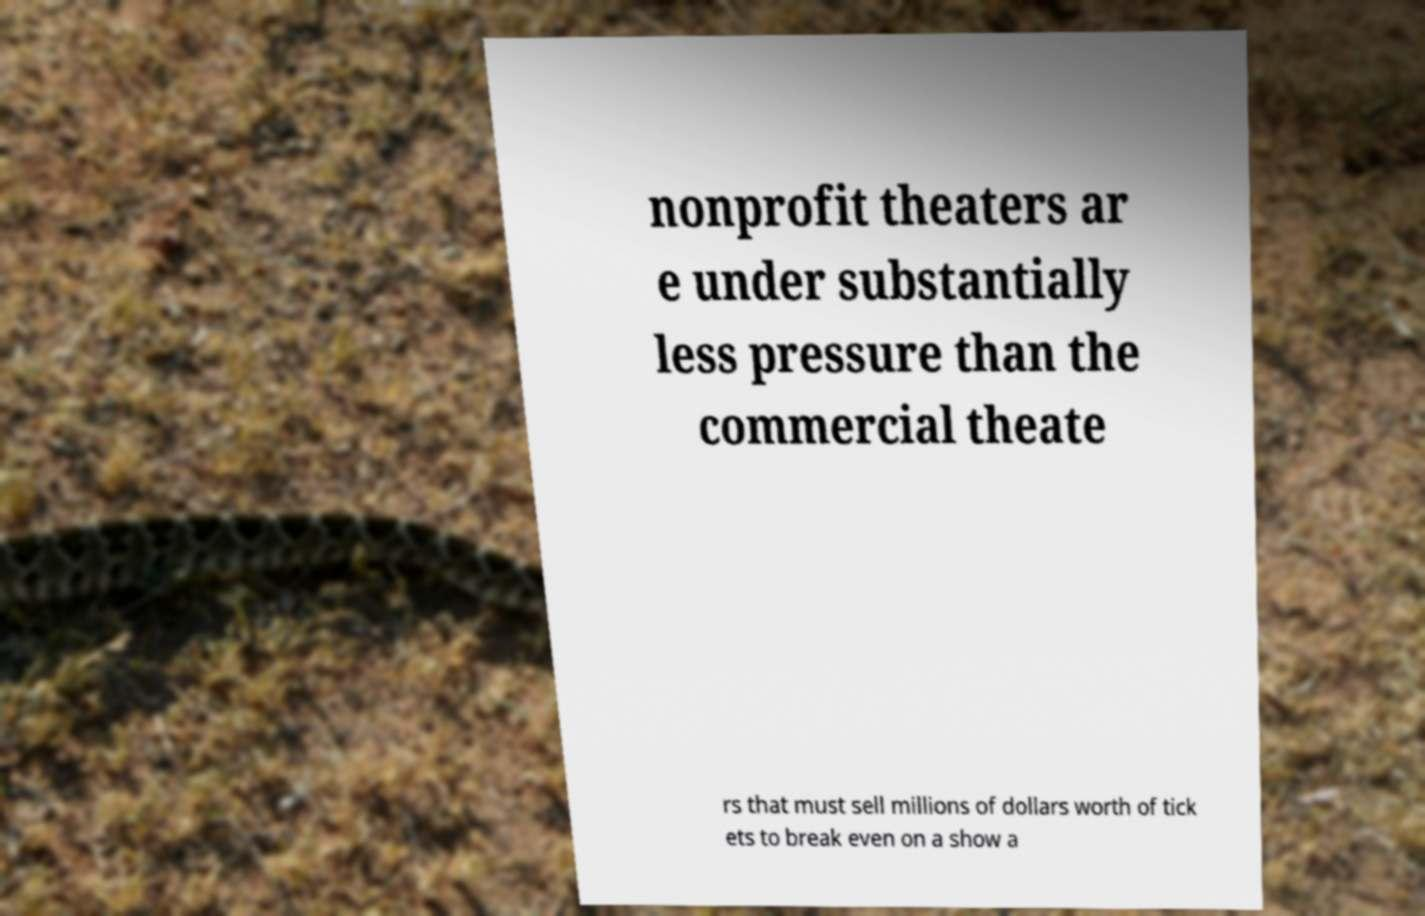Can you read and provide the text displayed in the image?This photo seems to have some interesting text. Can you extract and type it out for me? nonprofit theaters ar e under substantially less pressure than the commercial theate rs that must sell millions of dollars worth of tick ets to break even on a show a 